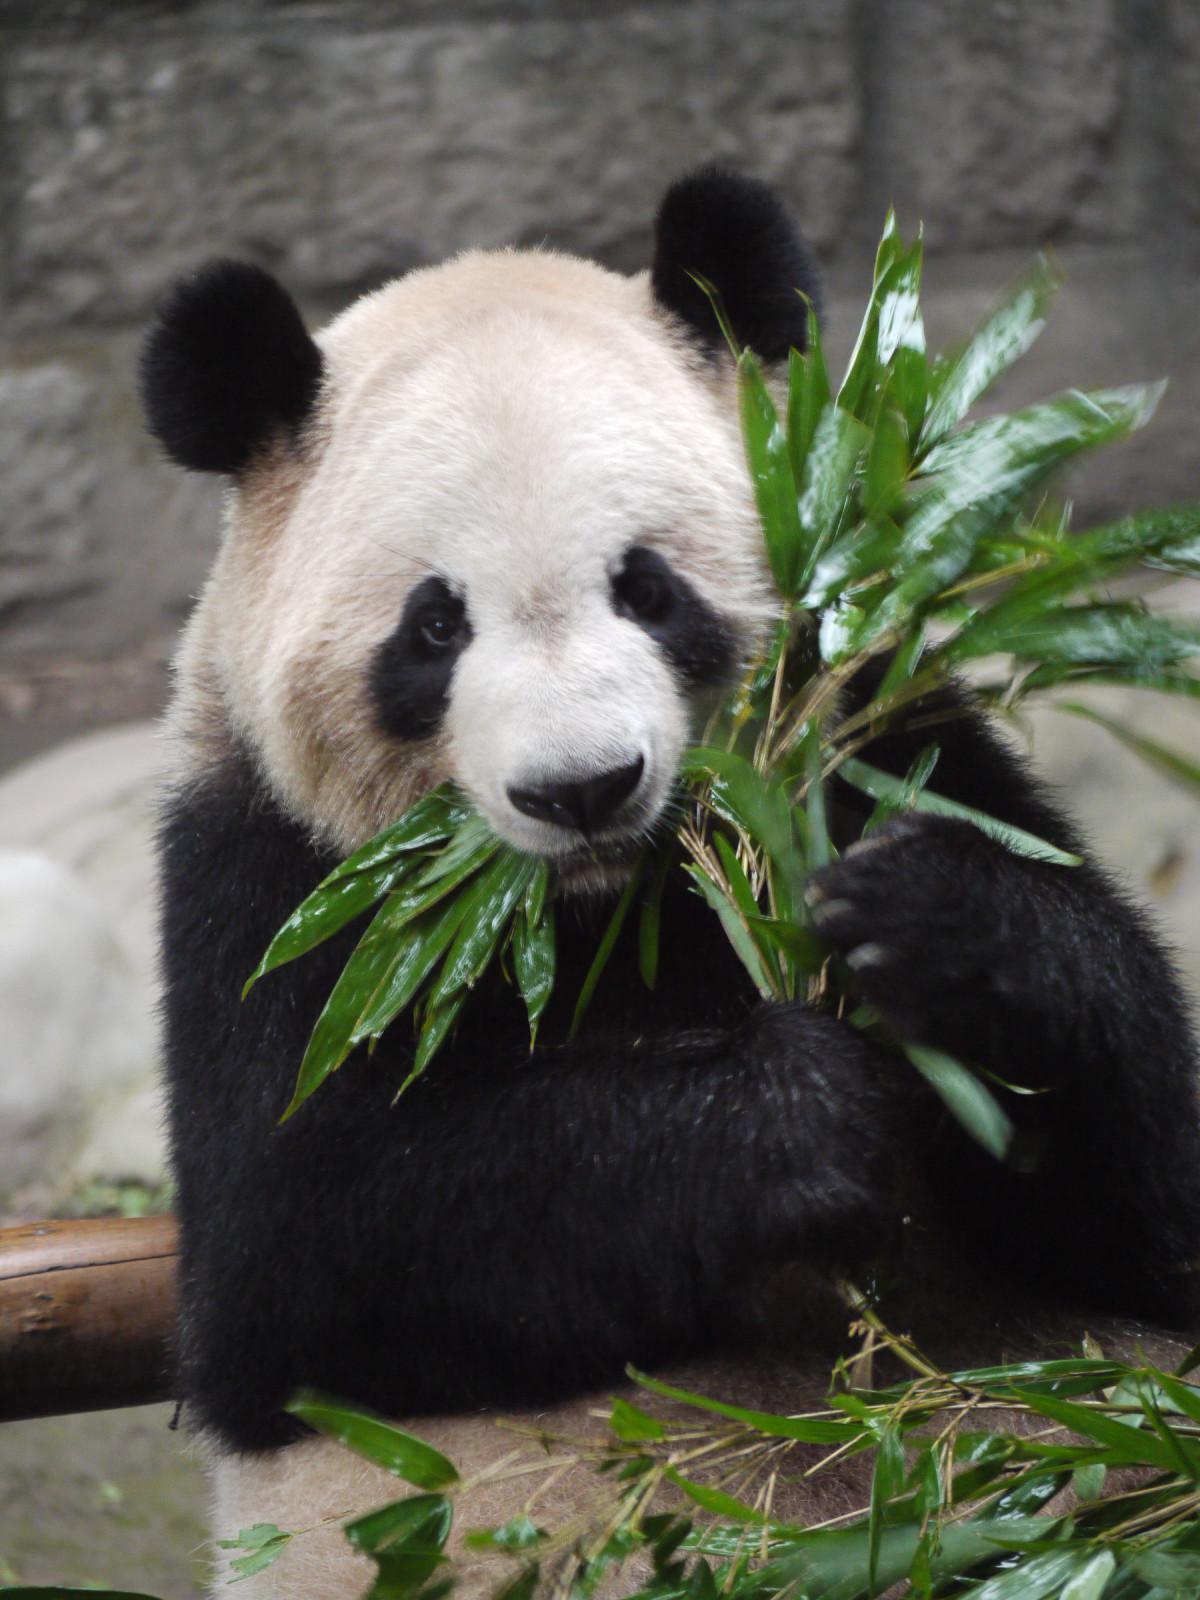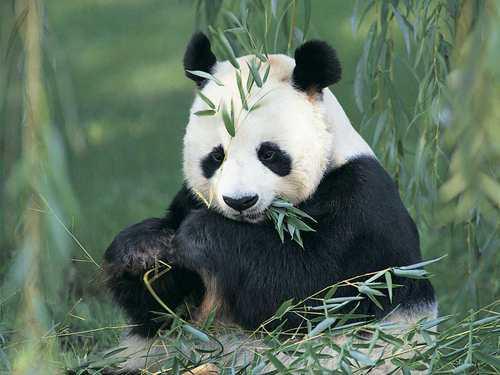The first image is the image on the left, the second image is the image on the right. For the images shown, is this caption "The right image shows two pandas." true? Answer yes or no. No. 